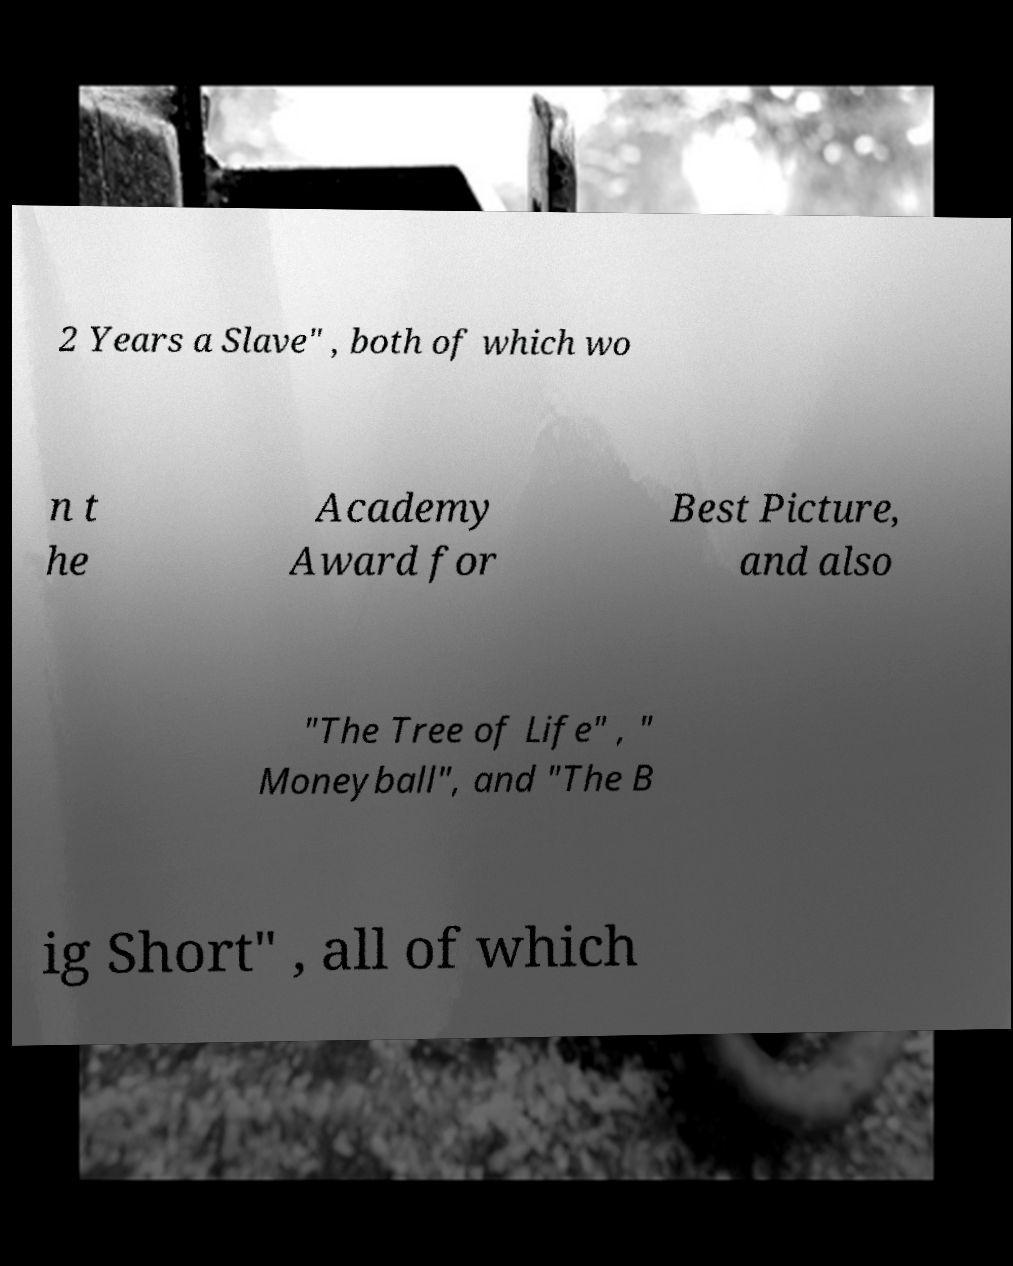I need the written content from this picture converted into text. Can you do that? 2 Years a Slave" , both of which wo n t he Academy Award for Best Picture, and also "The Tree of Life" , " Moneyball", and "The B ig Short" , all of which 